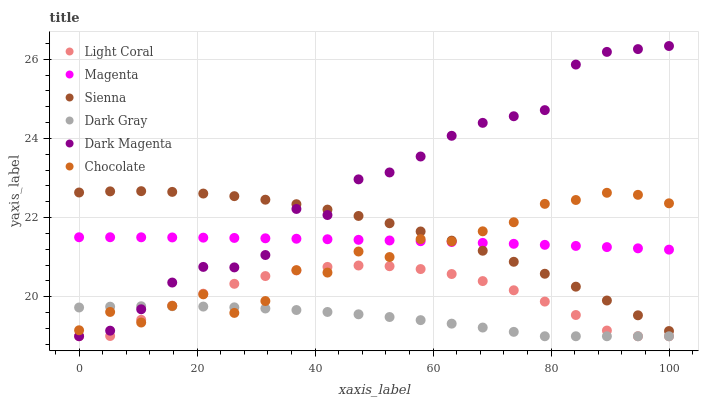Does Dark Gray have the minimum area under the curve?
Answer yes or no. Yes. Does Dark Magenta have the maximum area under the curve?
Answer yes or no. Yes. Does Chocolate have the minimum area under the curve?
Answer yes or no. No. Does Chocolate have the maximum area under the curve?
Answer yes or no. No. Is Magenta the smoothest?
Answer yes or no. Yes. Is Dark Magenta the roughest?
Answer yes or no. Yes. Is Chocolate the smoothest?
Answer yes or no. No. Is Chocolate the roughest?
Answer yes or no. No. Does Light Coral have the lowest value?
Answer yes or no. Yes. Does Dark Magenta have the lowest value?
Answer yes or no. No. Does Dark Magenta have the highest value?
Answer yes or no. Yes. Does Chocolate have the highest value?
Answer yes or no. No. Is Dark Gray less than Sienna?
Answer yes or no. Yes. Is Dark Magenta greater than Light Coral?
Answer yes or no. Yes. Does Dark Gray intersect Dark Magenta?
Answer yes or no. Yes. Is Dark Gray less than Dark Magenta?
Answer yes or no. No. Is Dark Gray greater than Dark Magenta?
Answer yes or no. No. Does Dark Gray intersect Sienna?
Answer yes or no. No. 